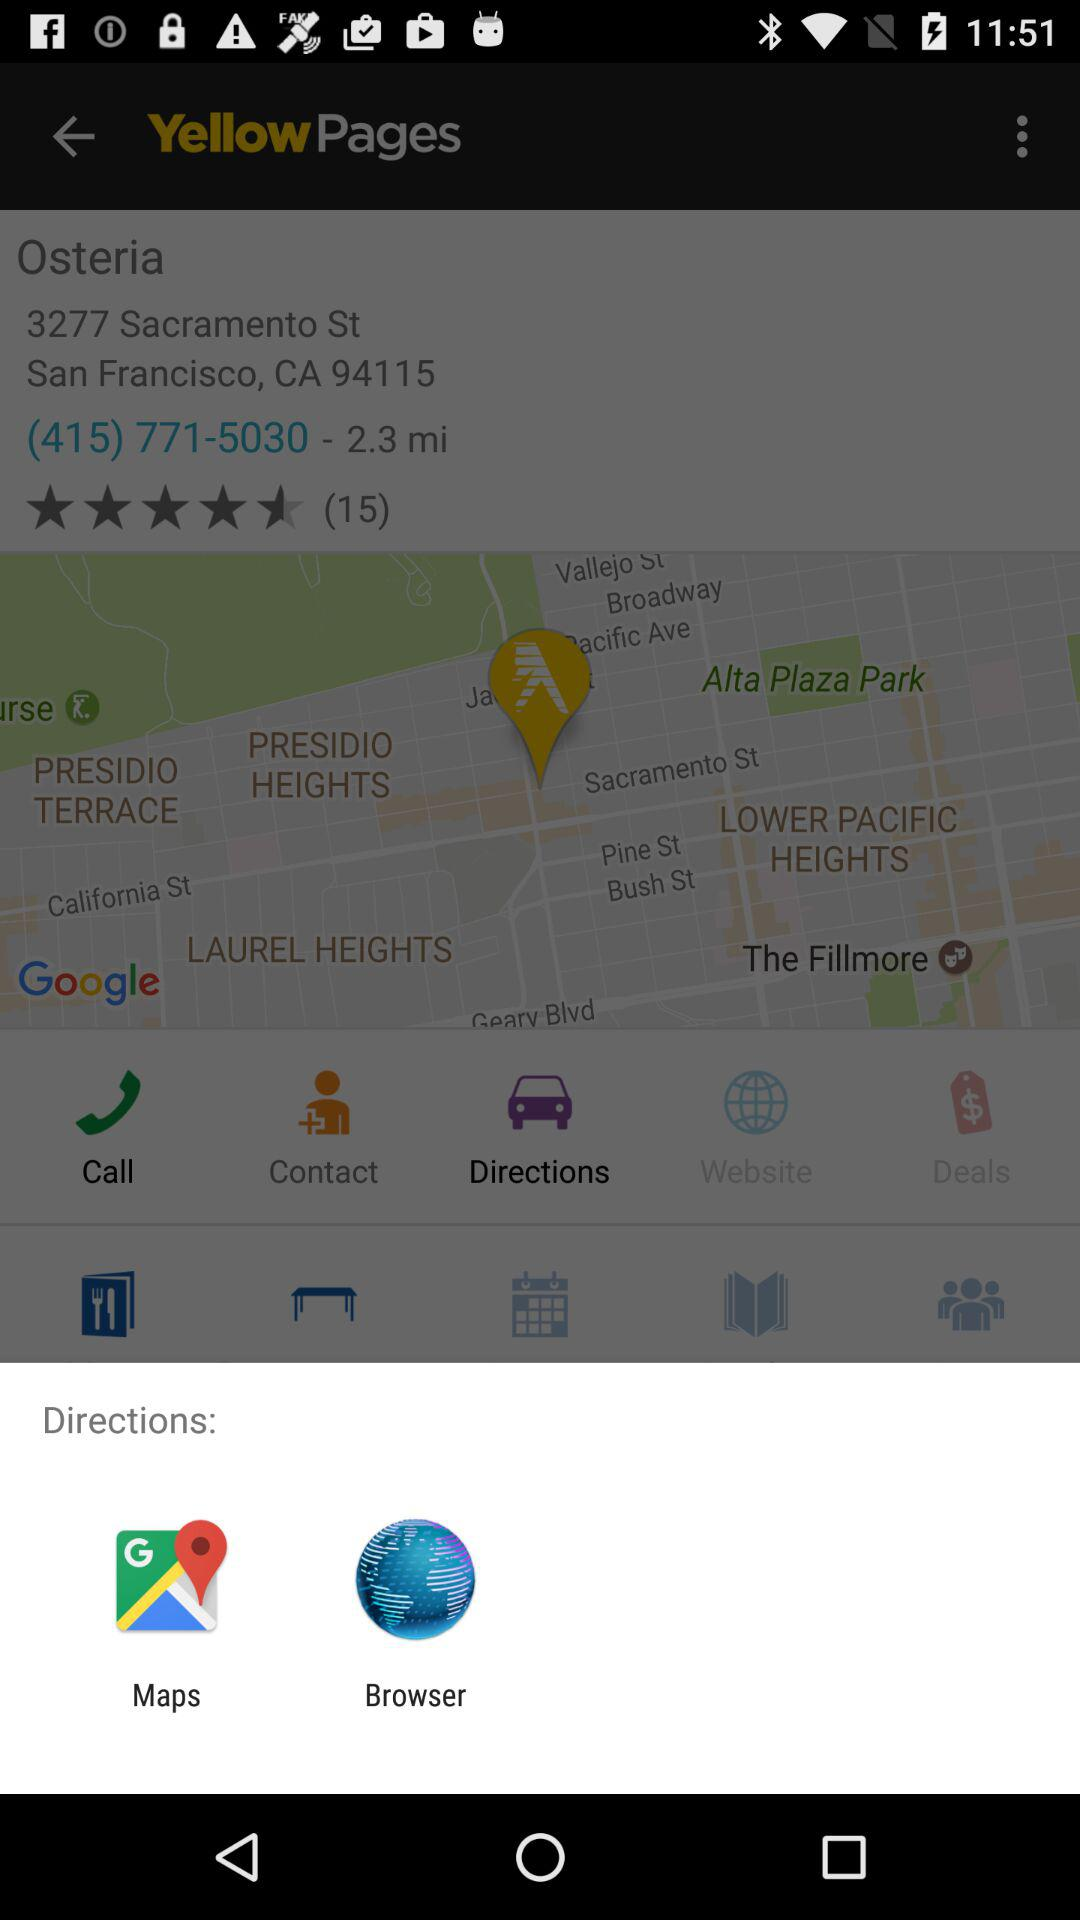Through which applications can we see the direction? You can see the direction through "Maps" and "Browser". 